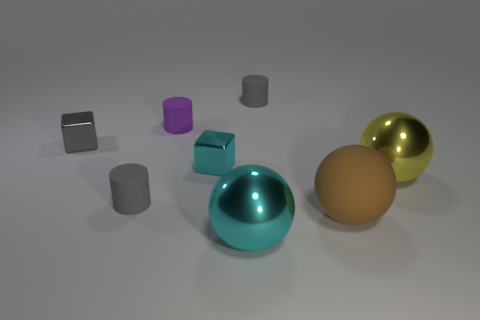If I were to arrange these objects from smallest to largest, what would that order look like? To arrange the objects from smallest to largest, you would likely start with the tiny purple rubber cylinder, followed by the silver cube, then the darker gray cylinder, followed by the light gray cylinder, and finally the three rubber balls, with the teal one being the smallest and the golden one being the largest. 